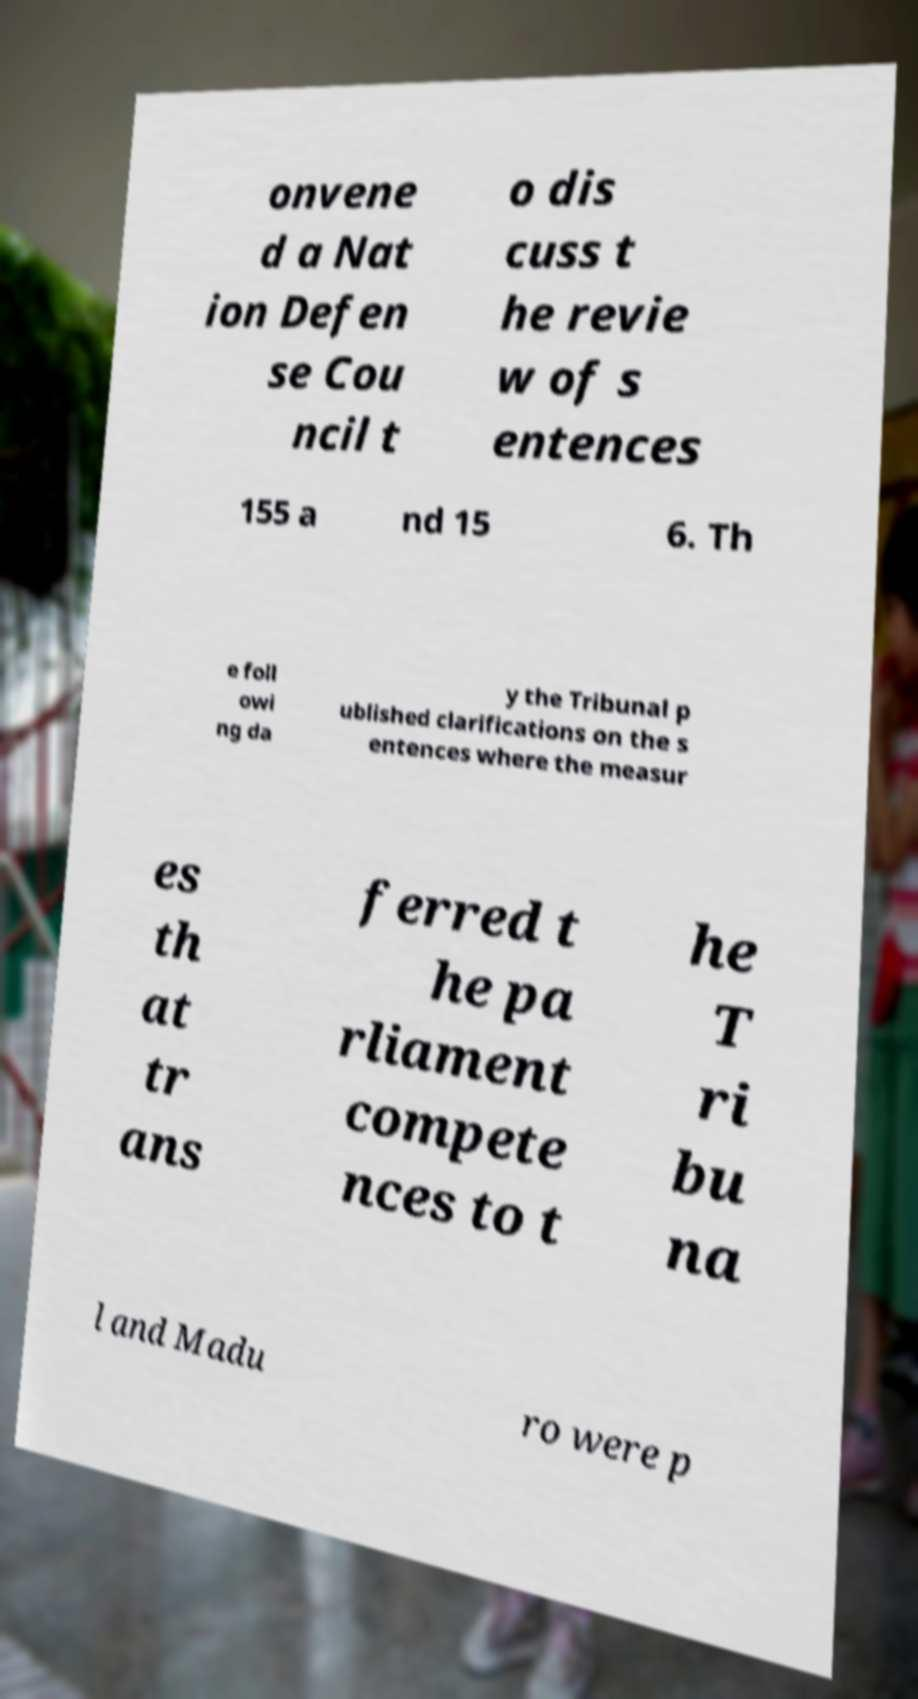I need the written content from this picture converted into text. Can you do that? onvene d a Nat ion Defen se Cou ncil t o dis cuss t he revie w of s entences 155 a nd 15 6. Th e foll owi ng da y the Tribunal p ublished clarifications on the s entences where the measur es th at tr ans ferred t he pa rliament compete nces to t he T ri bu na l and Madu ro were p 